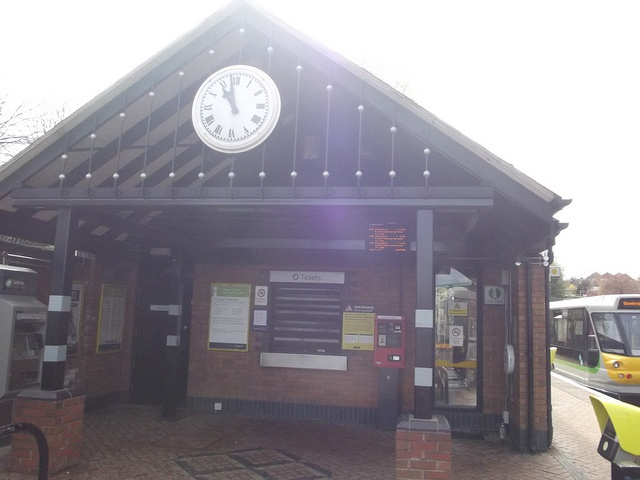Describe the objects in this image and their specific colors. I can see train in white, gray, darkgray, and tan tones and clock in white, darkgray, and lightgray tones in this image. 